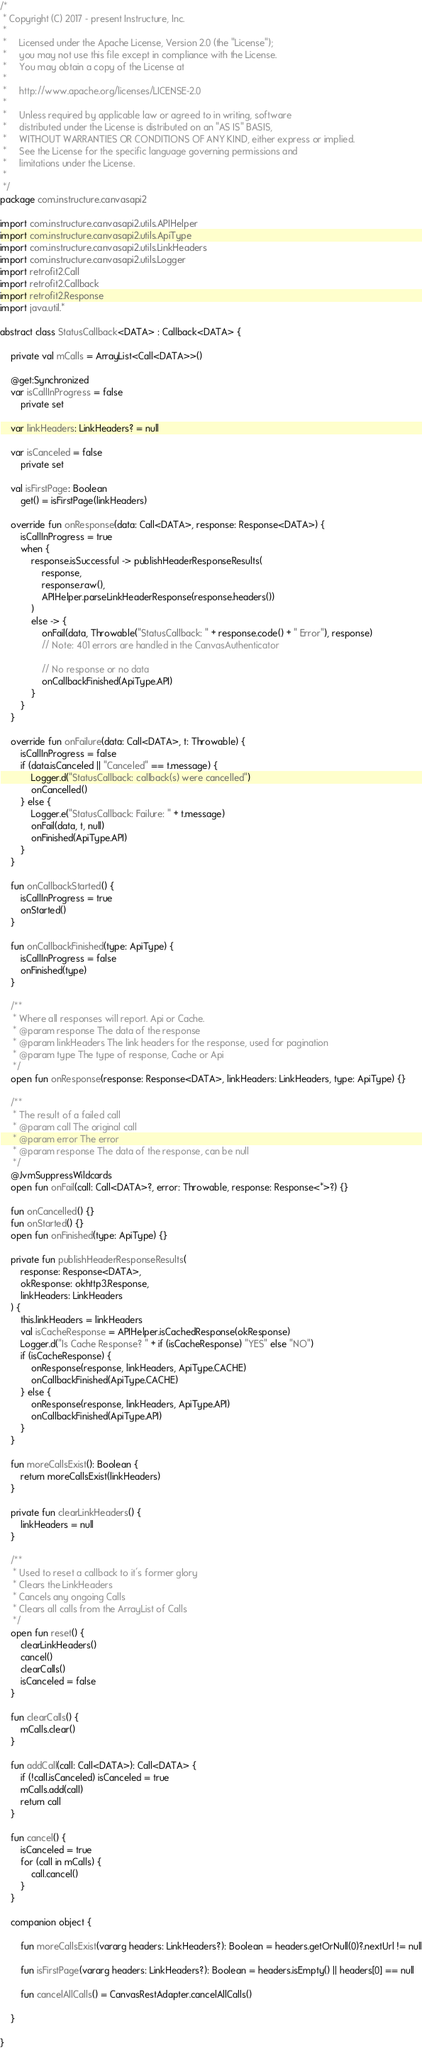<code> <loc_0><loc_0><loc_500><loc_500><_Kotlin_>/*
 * Copyright (C) 2017 - present Instructure, Inc.
 *
 *     Licensed under the Apache License, Version 2.0 (the "License");
 *     you may not use this file except in compliance with the License.
 *     You may obtain a copy of the License at
 *
 *     http://www.apache.org/licenses/LICENSE-2.0
 *
 *     Unless required by applicable law or agreed to in writing, software
 *     distributed under the License is distributed on an "AS IS" BASIS,
 *     WITHOUT WARRANTIES OR CONDITIONS OF ANY KIND, either express or implied.
 *     See the License for the specific language governing permissions and
 *     limitations under the License.
 *
 */
package com.instructure.canvasapi2

import com.instructure.canvasapi2.utils.APIHelper
import com.instructure.canvasapi2.utils.ApiType
import com.instructure.canvasapi2.utils.LinkHeaders
import com.instructure.canvasapi2.utils.Logger
import retrofit2.Call
import retrofit2.Callback
import retrofit2.Response
import java.util.*

abstract class StatusCallback<DATA> : Callback<DATA> {

    private val mCalls = ArrayList<Call<DATA>>()

    @get:Synchronized
    var isCallInProgress = false
        private set

    var linkHeaders: LinkHeaders? = null

    var isCanceled = false
        private set

    val isFirstPage: Boolean
        get() = isFirstPage(linkHeaders)

    override fun onResponse(data: Call<DATA>, response: Response<DATA>) {
        isCallInProgress = true
        when {
            response.isSuccessful -> publishHeaderResponseResults(
                response,
                response.raw(),
                APIHelper.parseLinkHeaderResponse(response.headers())
            )
            else -> {
                onFail(data, Throwable("StatusCallback: " + response.code() + " Error"), response)
                // Note: 401 errors are handled in the CanvasAuthenticator

                // No response or no data
                onCallbackFinished(ApiType.API)
            }
        }
    }

    override fun onFailure(data: Call<DATA>, t: Throwable) {
        isCallInProgress = false
        if (data.isCanceled || "Canceled" == t.message) {
            Logger.d("StatusCallback: callback(s) were cancelled")
            onCancelled()
        } else {
            Logger.e("StatusCallback: Failure: " + t.message)
            onFail(data, t, null)
            onFinished(ApiType.API)
        }
    }

    fun onCallbackStarted() {
        isCallInProgress = true
        onStarted()
    }

    fun onCallbackFinished(type: ApiType) {
        isCallInProgress = false
        onFinished(type)
    }

    /**
     * Where all responses will report. Api or Cache.
     * @param response The data of the response
     * @param linkHeaders The link headers for the response, used for pagination
     * @param type The type of response, Cache or Api
     */
    open fun onResponse(response: Response<DATA>, linkHeaders: LinkHeaders, type: ApiType) {}

    /**
     * The result of a failed call
     * @param call The original call
     * @param error The error
     * @param response The data of the response, can be null
     */
    @JvmSuppressWildcards
    open fun onFail(call: Call<DATA>?, error: Throwable, response: Response<*>?) {}

    fun onCancelled() {}
    fun onStarted() {}
    open fun onFinished(type: ApiType) {}

    private fun publishHeaderResponseResults(
        response: Response<DATA>,
        okResponse: okhttp3.Response,
        linkHeaders: LinkHeaders
    ) {
        this.linkHeaders = linkHeaders
        val isCacheResponse = APIHelper.isCachedResponse(okResponse)
        Logger.d("Is Cache Response? " + if (isCacheResponse) "YES" else "NO")
        if (isCacheResponse) {
            onResponse(response, linkHeaders, ApiType.CACHE)
            onCallbackFinished(ApiType.CACHE)
        } else {
            onResponse(response, linkHeaders, ApiType.API)
            onCallbackFinished(ApiType.API)
        }
    }

    fun moreCallsExist(): Boolean {
        return moreCallsExist(linkHeaders)
    }

    private fun clearLinkHeaders() {
        linkHeaders = null
    }

    /**
     * Used to reset a callback to it's former glory
     * Clears the LinkHeaders
     * Cancels any ongoing Calls
     * Clears all calls from the ArrayList of Calls
     */
    open fun reset() {
        clearLinkHeaders()
        cancel()
        clearCalls()
        isCanceled = false
    }

    fun clearCalls() {
        mCalls.clear()
    }

    fun addCall(call: Call<DATA>): Call<DATA> {
        if (!call.isCanceled) isCanceled = true
        mCalls.add(call)
        return call
    }

    fun cancel() {
        isCanceled = true
        for (call in mCalls) {
            call.cancel()
        }
    }

    companion object {

        fun moreCallsExist(vararg headers: LinkHeaders?): Boolean = headers.getOrNull(0)?.nextUrl != null

        fun isFirstPage(vararg headers: LinkHeaders?): Boolean = headers.isEmpty() || headers[0] == null

        fun cancelAllCalls() = CanvasRestAdapter.cancelAllCalls()

    }

}
</code> 